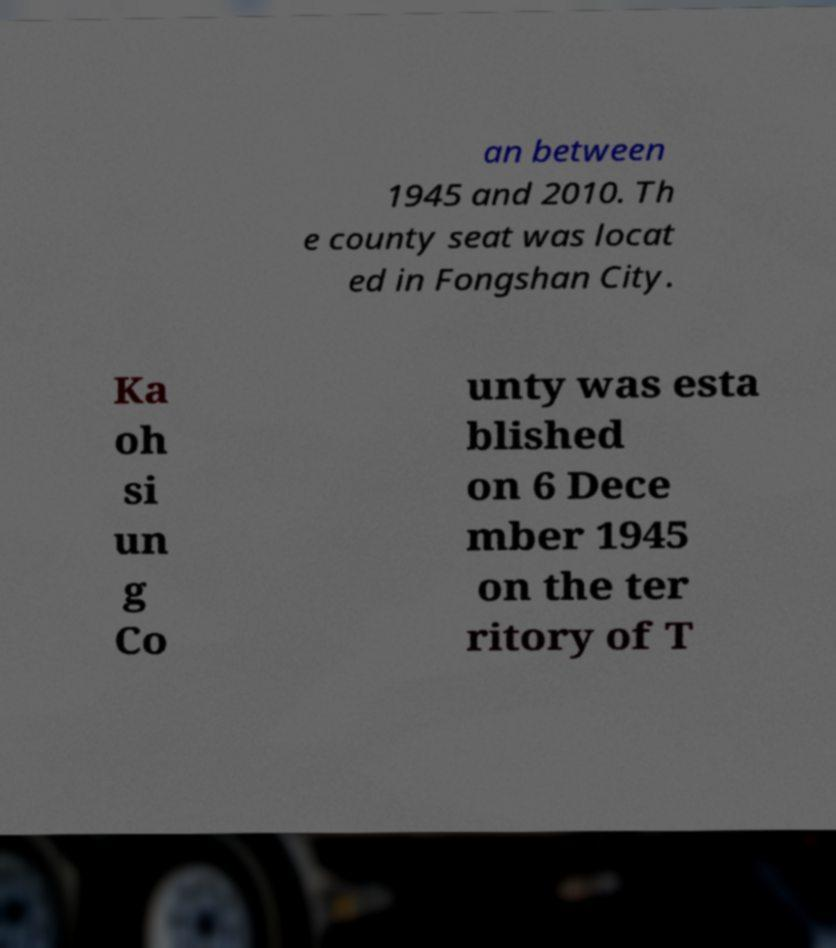Please identify and transcribe the text found in this image. an between 1945 and 2010. Th e county seat was locat ed in Fongshan City. Ka oh si un g Co unty was esta blished on 6 Dece mber 1945 on the ter ritory of T 